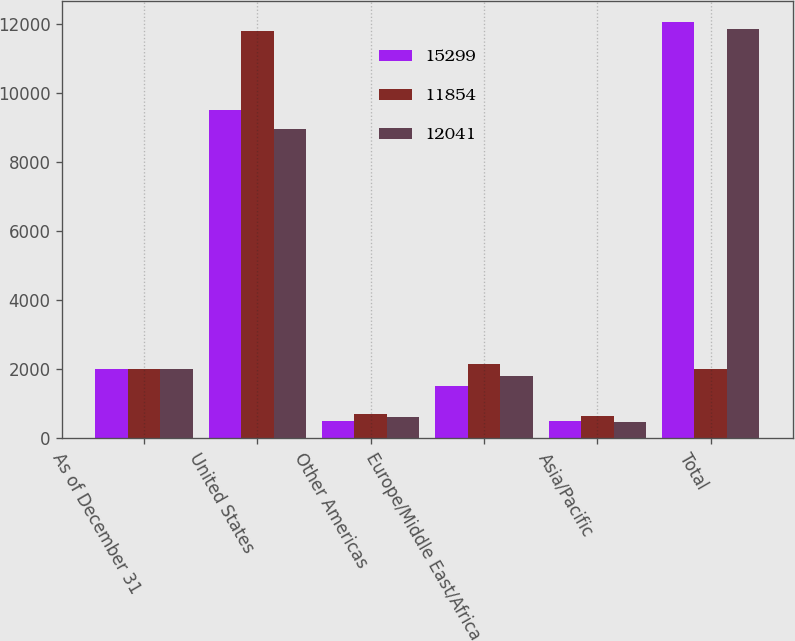Convert chart. <chart><loc_0><loc_0><loc_500><loc_500><stacked_bar_chart><ecel><fcel>As of December 31<fcel>United States<fcel>Other Americas<fcel>Europe/Middle East/Africa<fcel>Asia/Pacific<fcel>Total<nl><fcel>15299<fcel>2008<fcel>9506<fcel>498<fcel>1524<fcel>513<fcel>12041<nl><fcel>11854<fcel>2007<fcel>11792<fcel>698<fcel>2163<fcel>646<fcel>2006<nl><fcel>12041<fcel>2006<fcel>8962<fcel>607<fcel>1815<fcel>470<fcel>11854<nl></chart> 